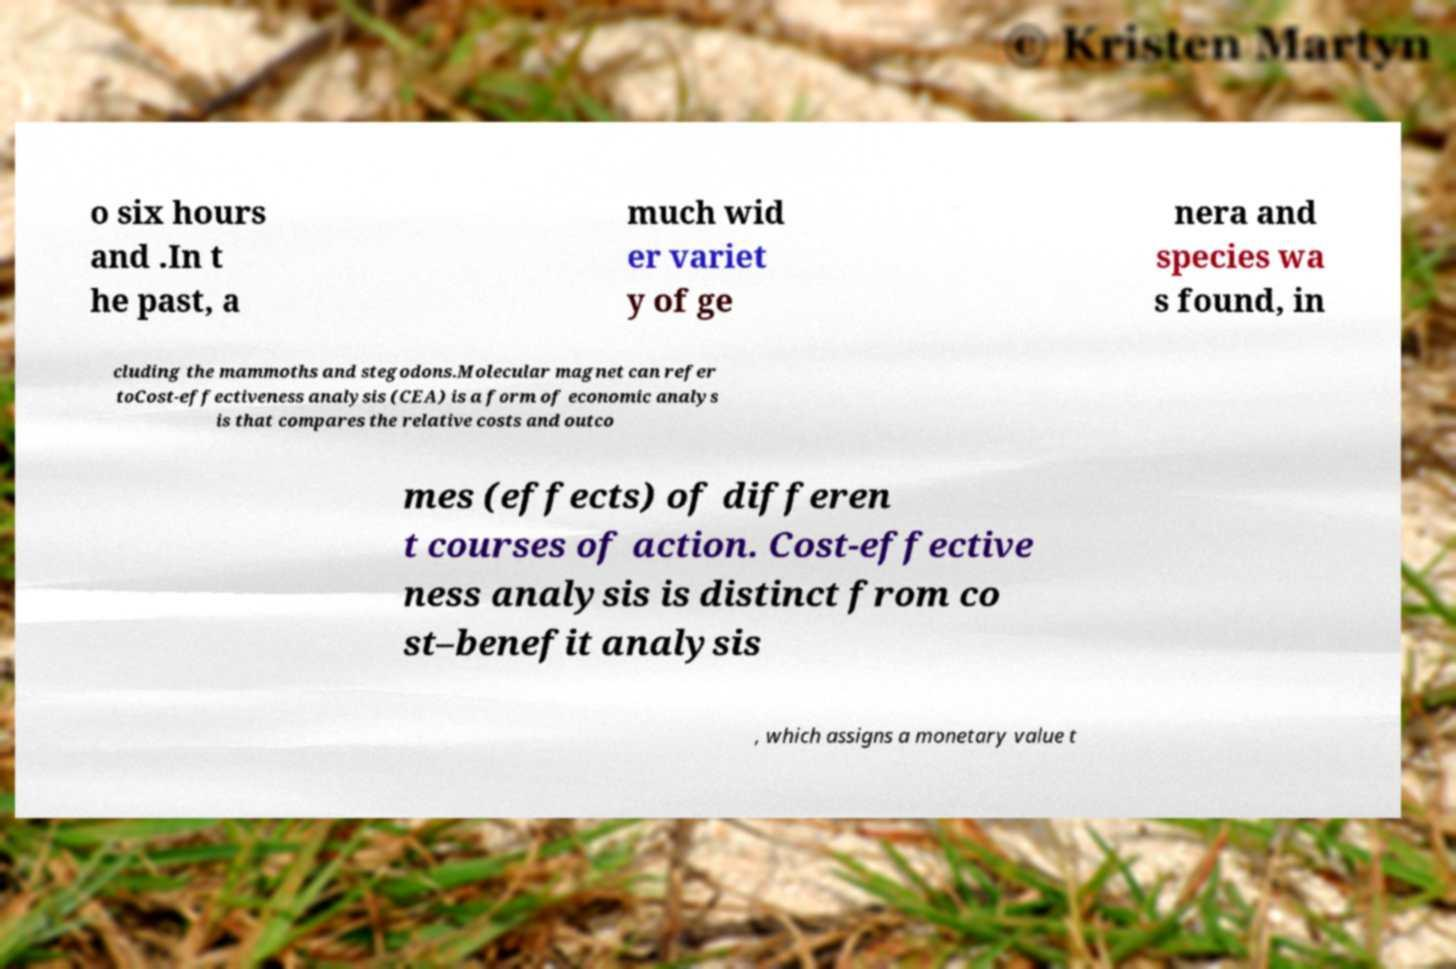Can you accurately transcribe the text from the provided image for me? o six hours and .In t he past, a much wid er variet y of ge nera and species wa s found, in cluding the mammoths and stegodons.Molecular magnet can refer toCost-effectiveness analysis (CEA) is a form of economic analys is that compares the relative costs and outco mes (effects) of differen t courses of action. Cost-effective ness analysis is distinct from co st–benefit analysis , which assigns a monetary value t 